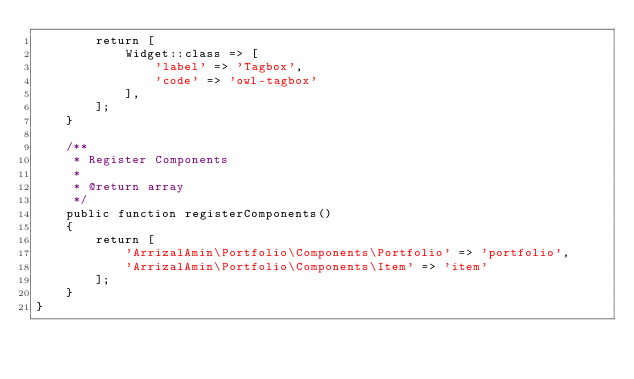<code> <loc_0><loc_0><loc_500><loc_500><_PHP_>        return [
            Widget::class => [
                'label' => 'Tagbox',
                'code' => 'owl-tagbox'
            ],
        ];
    }

    /**
     * Register Components
     *
     * @return array
     */
    public function registerComponents()
    {
        return [
            'ArrizalAmin\Portfolio\Components\Portfolio' => 'portfolio',
            'ArrizalAmin\Portfolio\Components\Item' => 'item'
        ];
    }
}
</code> 